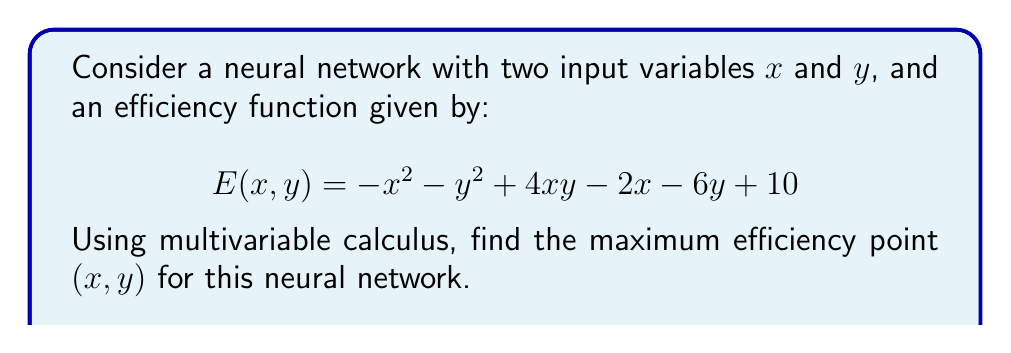Solve this math problem. To find the maximum efficiency point, we need to follow these steps:

1) Find the partial derivatives of $E$ with respect to $x$ and $y$:

   $$\frac{\partial E}{\partial x} = -2x + 4y - 2$$
   $$\frac{\partial E}{\partial y} = -2y + 4x - 6$$

2) Set both partial derivatives to zero to find critical points:

   $$-2x + 4y - 2 = 0 \quad (1)$$
   $$-2y + 4x - 6 = 0 \quad (2)$$

3) Solve this system of equations:
   From (1): $y = \frac{x + 1}{2} \quad (3)$
   
   Substitute (3) into (2):
   $$-2(\frac{x + 1}{2}) + 4x - 6 = 0$$
   $$-x - 1 + 4x - 6 = 0$$
   $$3x = 7$$
   $$x = \frac{7}{3}$$

   Substitute this $x$ value back into (3):
   $$y = \frac{\frac{7}{3} + 1}{2} = \frac{10}{6} = \frac{5}{3}$$

4) Verify it's a maximum using the second derivative test:

   $$\frac{\partial^2 E}{\partial x^2} = -2$$
   $$\frac{\partial^2 E}{\partial y^2} = -2$$
   $$\frac{\partial^2 E}{\partial x \partial y} = 4$$

   Hessian determinant: $(-2)(-2) - (4)^2 = 4 - 16 = -12 < 0$
   
   Since the Hessian is negative and $\frac{\partial^2 E}{\partial x^2} < 0$, this critical point is a local maximum.

5) Therefore, the maximum efficiency point is $(\frac{7}{3}, \frac{5}{3})$.
Answer: $(\frac{7}{3}, \frac{5}{3})$ 